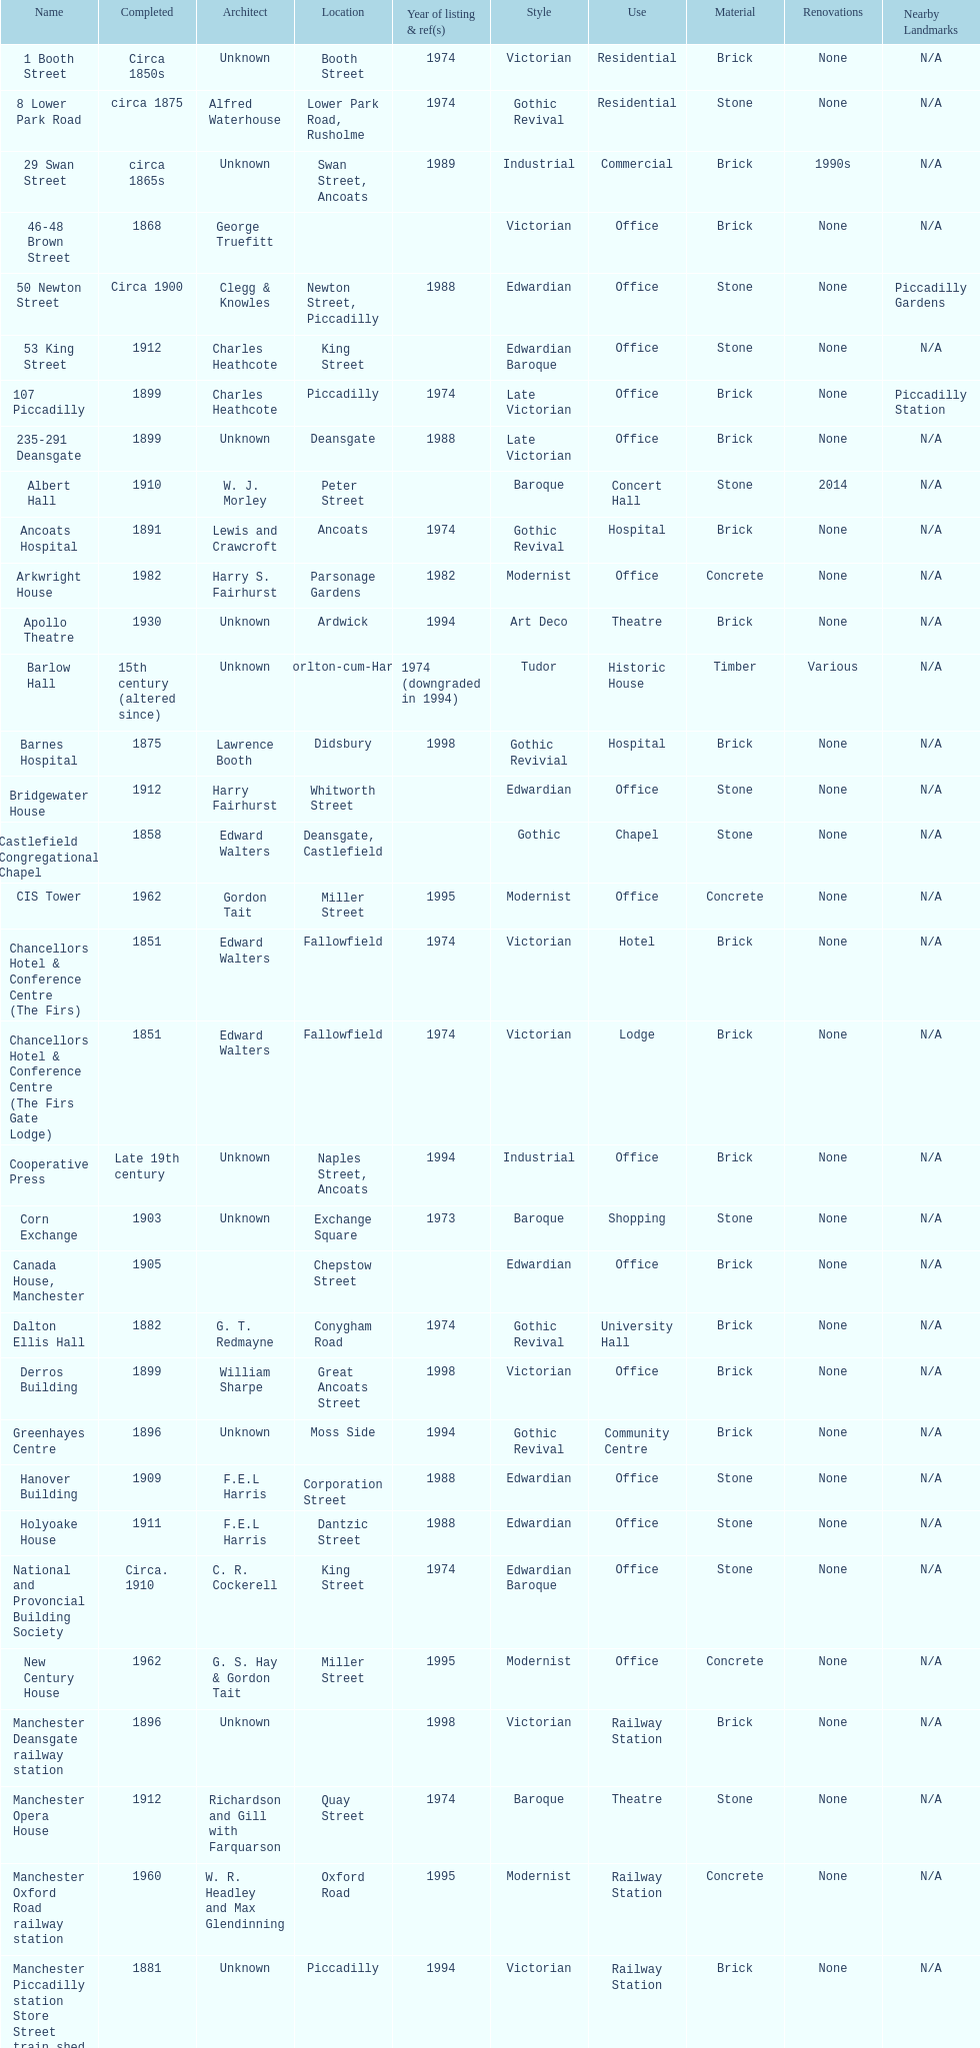How many years apart were the completion dates of 53 king street and castlefield congregational chapel? 54 years. 